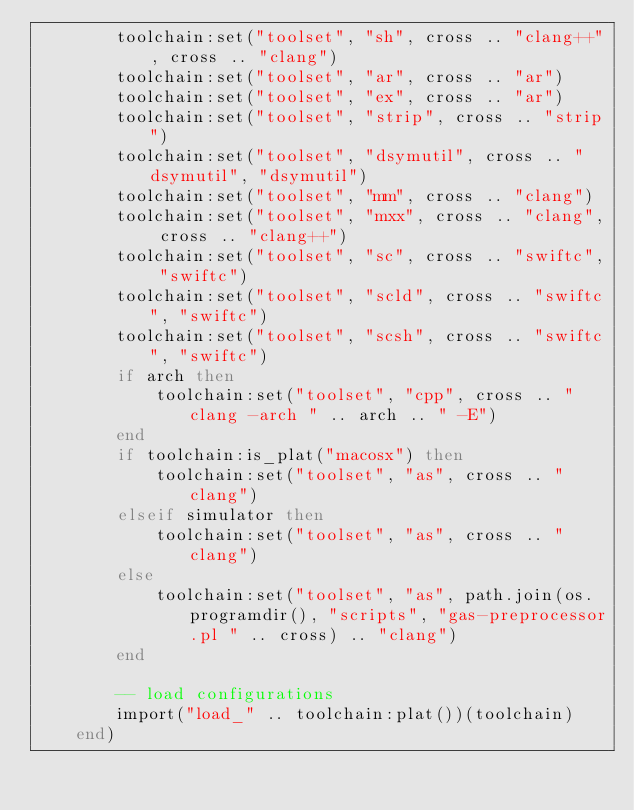<code> <loc_0><loc_0><loc_500><loc_500><_Lua_>        toolchain:set("toolset", "sh", cross .. "clang++", cross .. "clang")
        toolchain:set("toolset", "ar", cross .. "ar")
        toolchain:set("toolset", "ex", cross .. "ar")
        toolchain:set("toolset", "strip", cross .. "strip")
        toolchain:set("toolset", "dsymutil", cross .. "dsymutil", "dsymutil")
        toolchain:set("toolset", "mm", cross .. "clang")
        toolchain:set("toolset", "mxx", cross .. "clang", cross .. "clang++")
        toolchain:set("toolset", "sc", cross .. "swiftc", "swiftc")
        toolchain:set("toolset", "scld", cross .. "swiftc", "swiftc")
        toolchain:set("toolset", "scsh", cross .. "swiftc", "swiftc")
        if arch then
            toolchain:set("toolset", "cpp", cross .. "clang -arch " .. arch .. " -E")
        end
        if toolchain:is_plat("macosx") then
            toolchain:set("toolset", "as", cross .. "clang")
        elseif simulator then
            toolchain:set("toolset", "as", cross .. "clang")
        else
            toolchain:set("toolset", "as", path.join(os.programdir(), "scripts", "gas-preprocessor.pl " .. cross) .. "clang")
        end

        -- load configurations
        import("load_" .. toolchain:plat())(toolchain)
    end)
</code> 